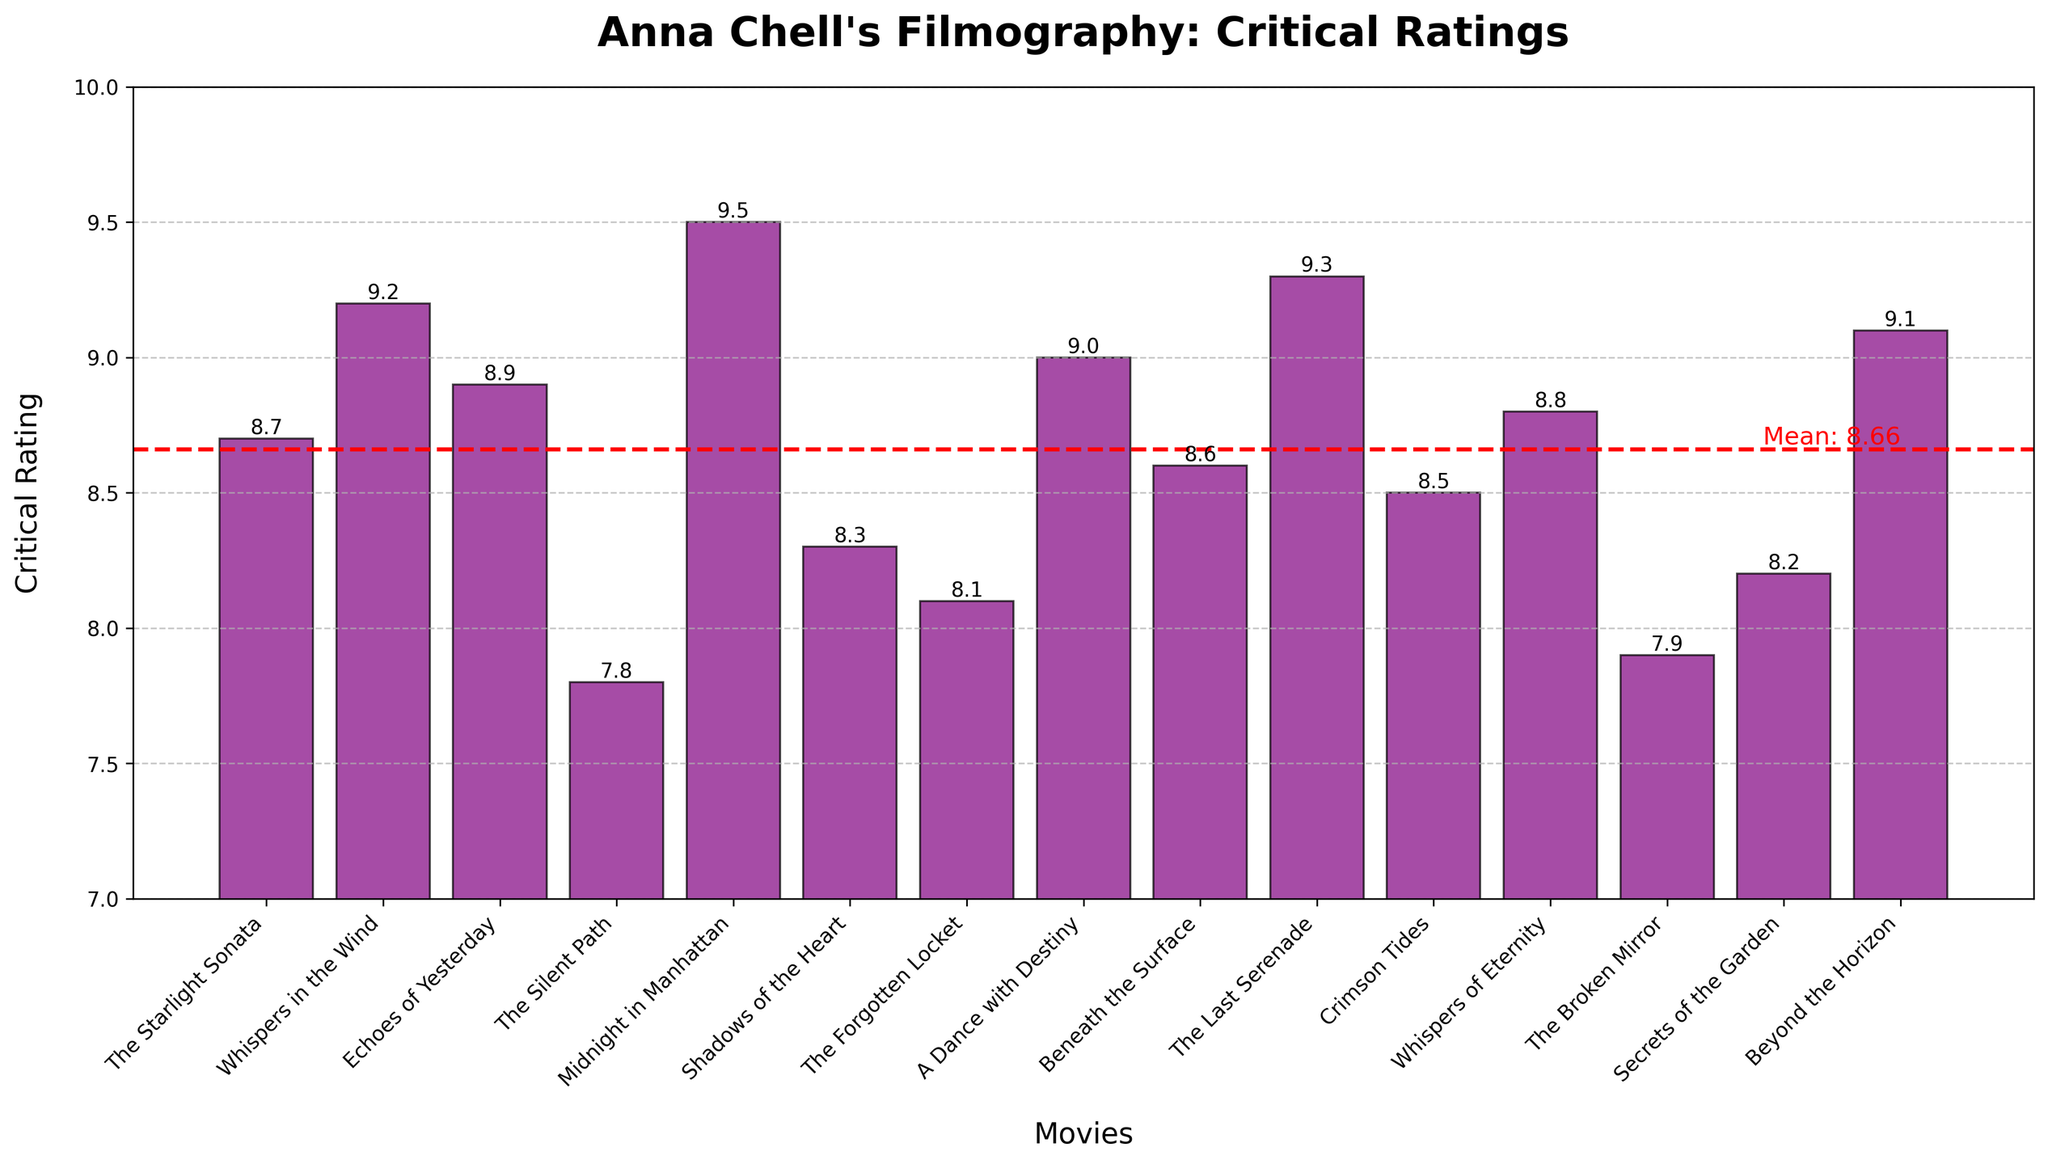Which movie has the highest critical rating? The highest bar on the chart represents the movie with the highest critical rating. This bar belongs to "Midnight in Manhattan" with a rating of 9.5.
Answer: Midnight in Manhattan Which movie has the lowest critical rating? The shortest bar on the chart represents the movie with the lowest critical rating. This bar belongs to "The Silent Path" with a rating of 7.8.
Answer: The Silent Path What is the average critical rating of Anna Chell's movies? There's a red horizontal line on the chart indicating the mean rating. The label next to the line shows the mean rating of 8.68.
Answer: 8.68 How many movies have a critical rating higher than the mean? First, locate the mean line at 8.68. Count the bars that extend above this line. There are 8 bars above the mean rating.
Answer: 8 Which movies have a critical rating equal to or higher than 9.0? Look for bars that reach the 9.0 mark or higher. These movies are "Whispers in the Wind," "Midnight in Manhattan," "A Dance with Destiny," "The Last Serenade," and "Beyond the Horizon."
Answer: Whispers in the Wind, Midnight in Manhattan, A Dance with Destiny, The Last Serenade, Beyond the Horizon What's the difference in critical rating between the highest-rated and the lowest-rated movie? The highest-rated movie is "Midnight in Manhattan" with 9.5, and the lowest-rated movie is "The Silent Path" with 7.8. The difference is 9.5 - 7.8 = 1.7.
Answer: 1.7 Which movies are rated between 8.0 and 8.5 inclusive? Identify the bars falling within the range of 8.0 to 8.5. These movies are "The Broken Mirror," "The Forgotten Locket," "Secrets of the Garden," "Shadows of the Heart," "Crimson Tides," and "Beneath the Surface."
Answer: The Broken Mirror, The Forgotten Locket, Secrets of the Garden, Shadows of the Heart, Crimson Tides, Beneath the Surface What is the median critical rating of the movies? To find the median, list the critical ratings in ascending order and find the middle value. In this case, there are 15 movies, so the median is the 8th value: 7.8, 7.9, 8.1, 8.2, 8.3, 8.5, 8.6, **8.7**, 8.8, 8.9, 9.0, 9.1, 9.2, 9.3, 9.5. The median rating is 8.7.
Answer: 8.7 How many movies have a rating below 8.0? Look at the chart to identify the bars that fall below the 8.0 mark. There are two such bars: "The Silent Path" and "The Broken Mirror."
Answer: 2 